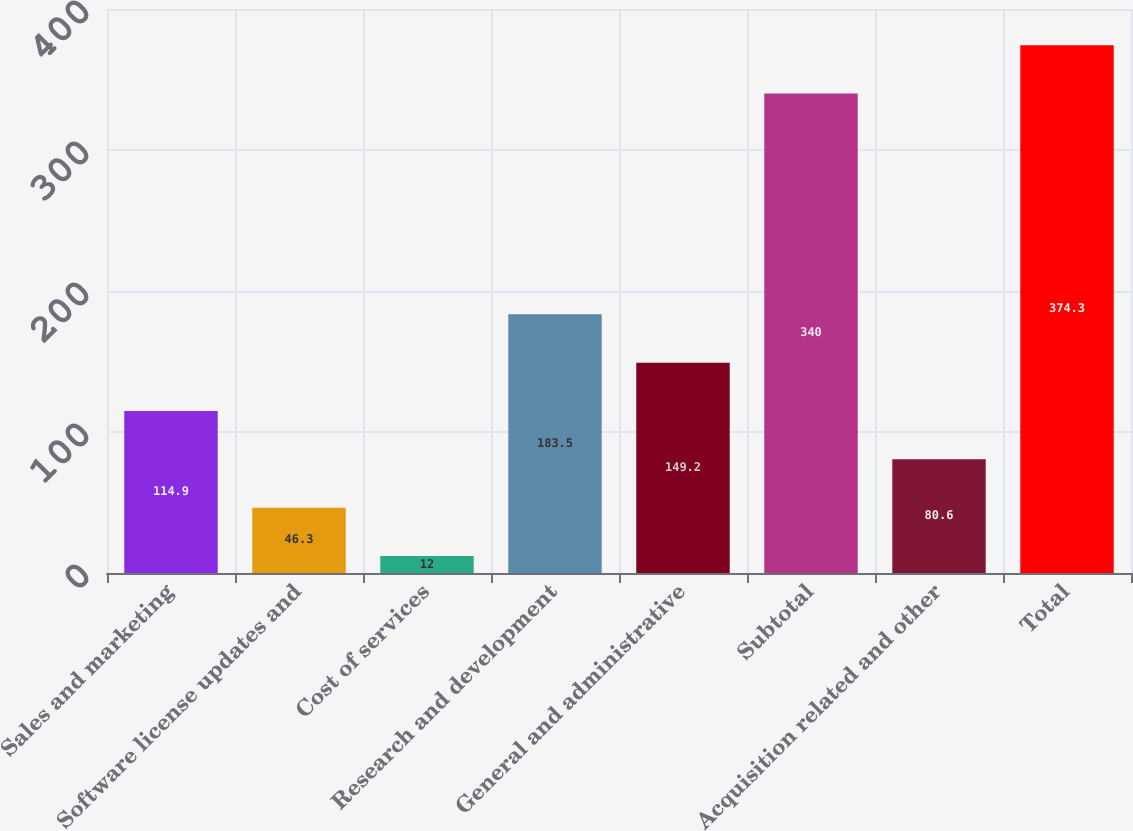<chart> <loc_0><loc_0><loc_500><loc_500><bar_chart><fcel>Sales and marketing<fcel>Software license updates and<fcel>Cost of services<fcel>Research and development<fcel>General and administrative<fcel>Subtotal<fcel>Acquisition related and other<fcel>Total<nl><fcel>114.9<fcel>46.3<fcel>12<fcel>183.5<fcel>149.2<fcel>340<fcel>80.6<fcel>374.3<nl></chart> 